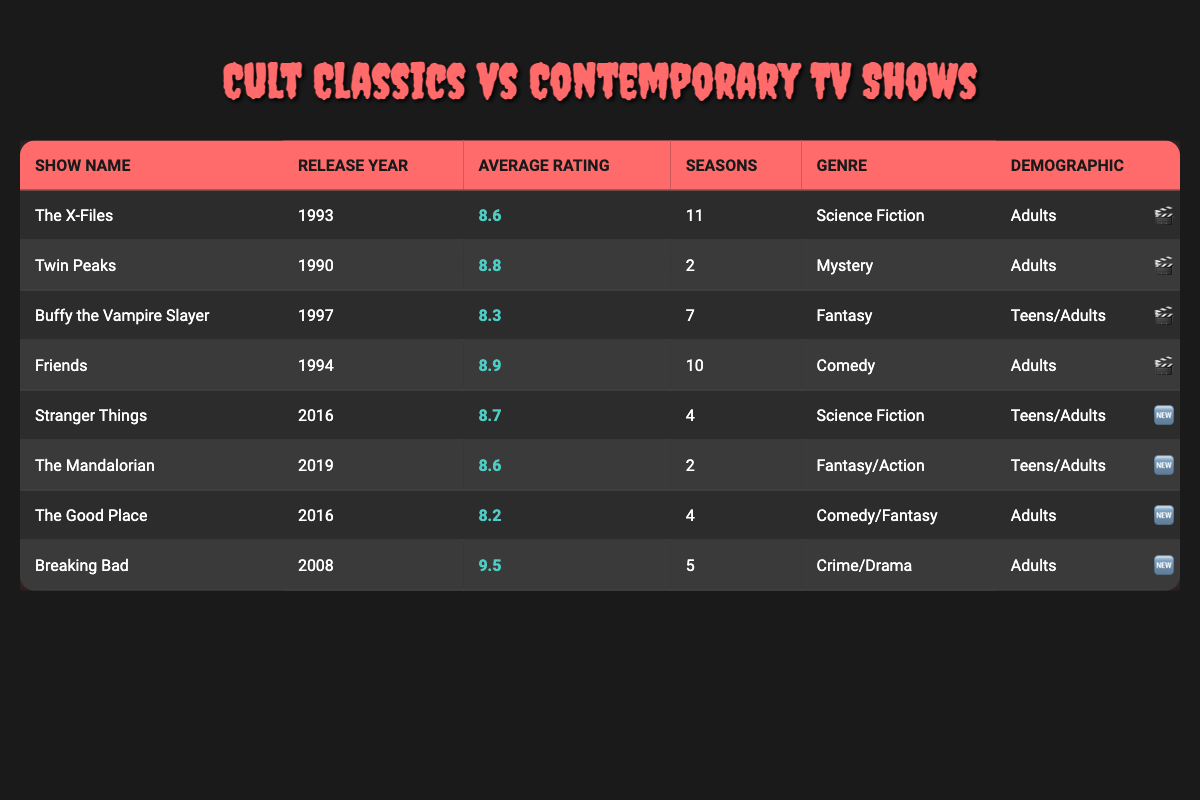What is the average rating of "Friends"? The table lists "Friends" with an average rating of 8.9. Therefore, the average rating is directly provided in the table without needing further calculation.
Answer: 8.9 Which show has the highest average rating? Looking through the table, "Breaking Bad" has the highest average rating of 9.5, as this value is greater than all other shows listed.
Answer: Breaking Bad What is the average number of seasons for cult classic shows? The cult classic shows are: The X-Files (11), Twin Peaks (2), Buffy the Vampire Slayer (7), and Friends (10). To find the average, sum these numbers: 11 + 2 + 7 + 10 = 30. There are 4 shows, so the average is 30/4 = 7.5.
Answer: 7.5 Does "Stranger Things" target teens/adults? The table shows "Stranger Things" has a demographic of "Teens/Adults," which confirms that this is true.
Answer: Yes Which show released in the same year as "The Mandalorian"? The Mandalorian was released in 2019. Looking through the table, the only show released in 2019 is itself, as no other series in the table shares this release year.
Answer: The Mandalorian 